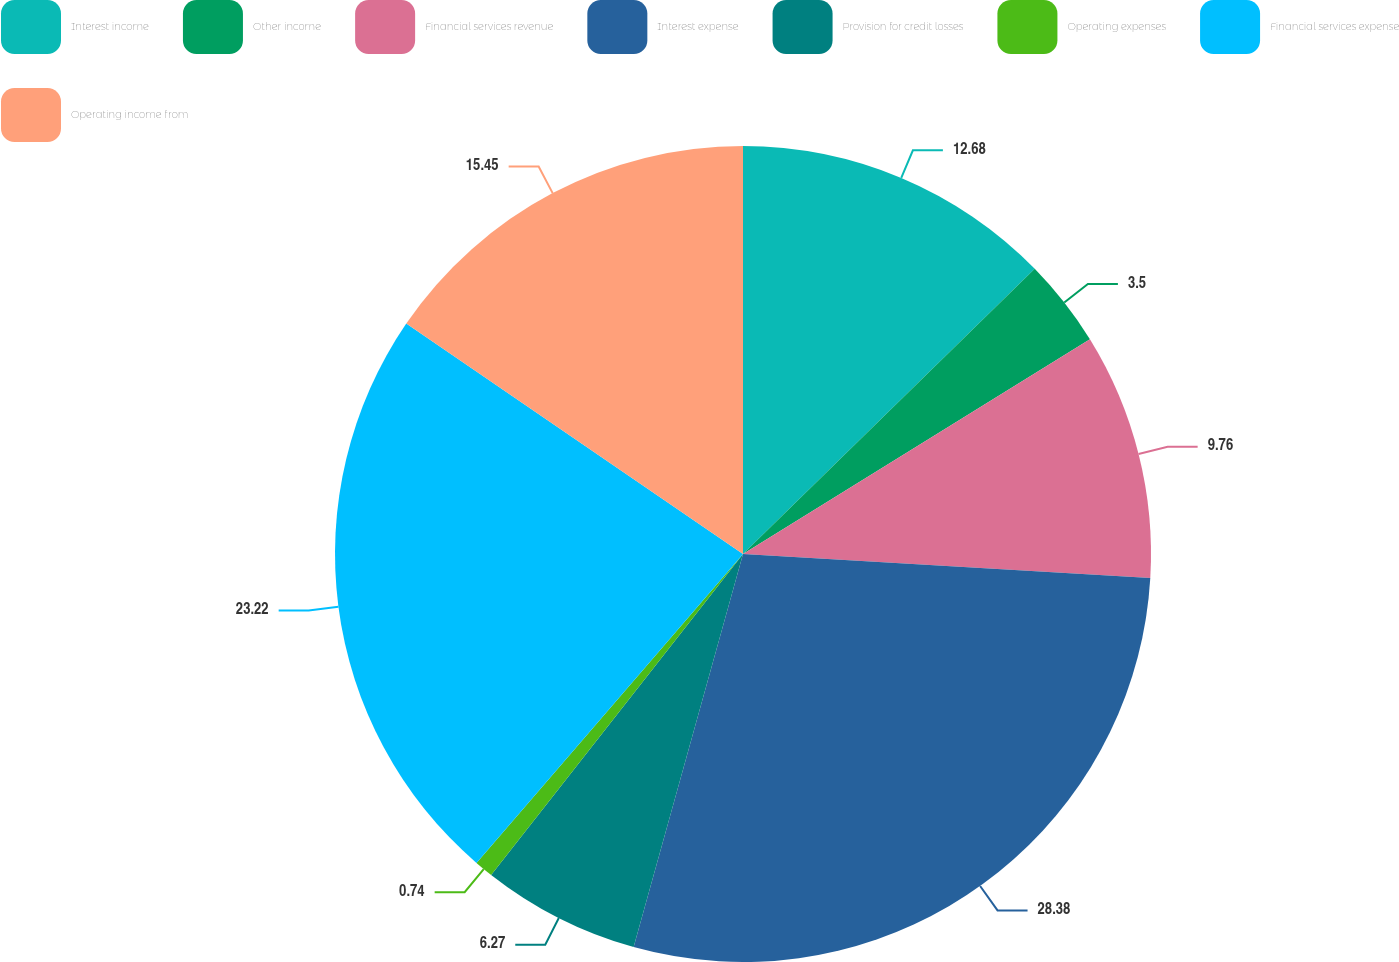Convert chart. <chart><loc_0><loc_0><loc_500><loc_500><pie_chart><fcel>Interest income<fcel>Other income<fcel>Financial services revenue<fcel>Interest expense<fcel>Provision for credit losses<fcel>Operating expenses<fcel>Financial services expense<fcel>Operating income from<nl><fcel>12.68%<fcel>3.5%<fcel>9.76%<fcel>28.38%<fcel>6.27%<fcel>0.74%<fcel>23.22%<fcel>15.45%<nl></chart> 